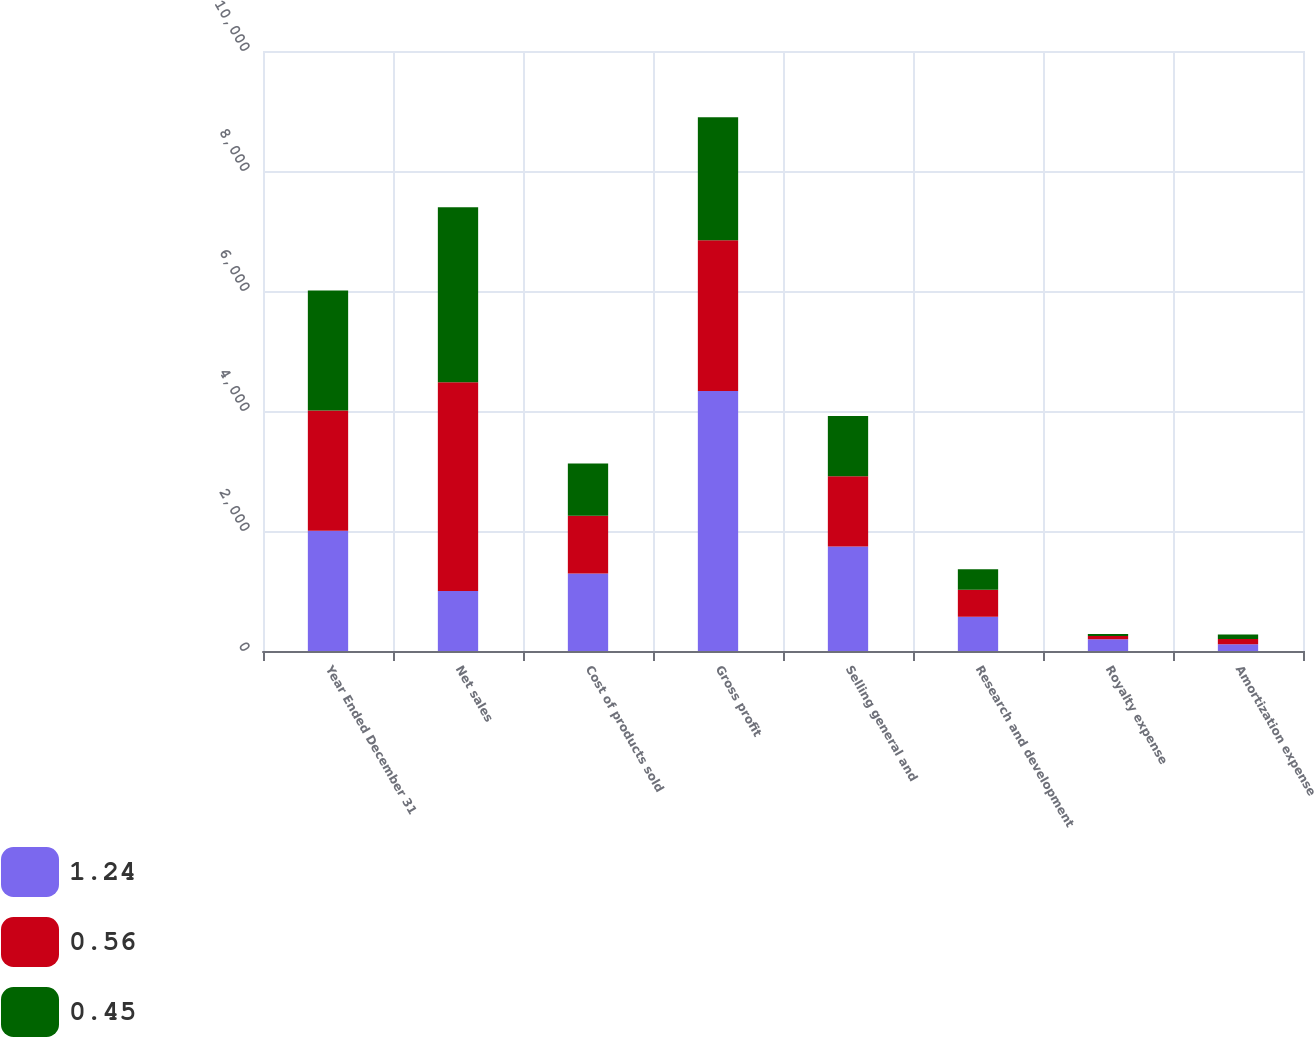Convert chart to OTSL. <chart><loc_0><loc_0><loc_500><loc_500><stacked_bar_chart><ecel><fcel>Year Ended December 31<fcel>Net sales<fcel>Cost of products sold<fcel>Gross profit<fcel>Selling general and<fcel>Research and development<fcel>Royalty expense<fcel>Amortization expense<nl><fcel>1.24<fcel>2004<fcel>1002<fcel>1292<fcel>4332<fcel>1742<fcel>569<fcel>195<fcel>112<nl><fcel>0.56<fcel>2003<fcel>3476<fcel>961<fcel>2515<fcel>1171<fcel>452<fcel>54<fcel>89<nl><fcel>0.45<fcel>2002<fcel>2919<fcel>870<fcel>2049<fcel>1002<fcel>343<fcel>36<fcel>72<nl></chart> 